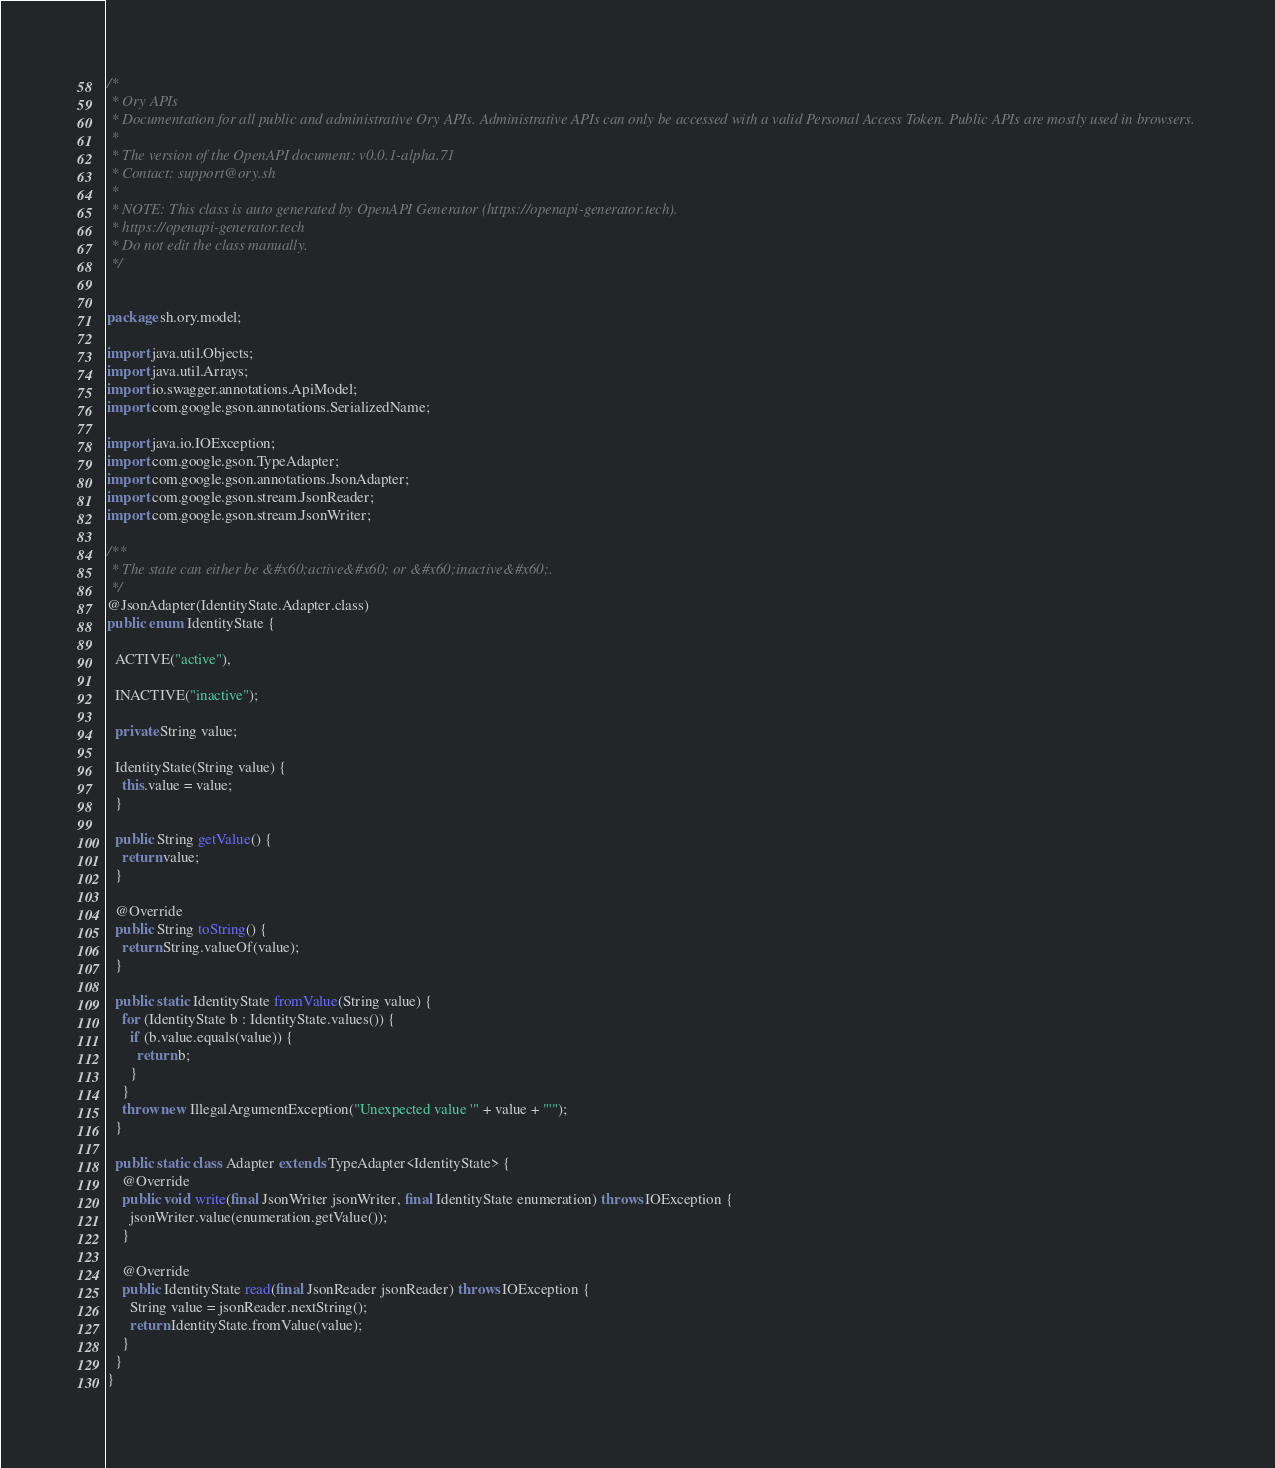<code> <loc_0><loc_0><loc_500><loc_500><_Java_>/*
 * Ory APIs
 * Documentation for all public and administrative Ory APIs. Administrative APIs can only be accessed with a valid Personal Access Token. Public APIs are mostly used in browsers. 
 *
 * The version of the OpenAPI document: v0.0.1-alpha.71
 * Contact: support@ory.sh
 *
 * NOTE: This class is auto generated by OpenAPI Generator (https://openapi-generator.tech).
 * https://openapi-generator.tech
 * Do not edit the class manually.
 */


package sh.ory.model;

import java.util.Objects;
import java.util.Arrays;
import io.swagger.annotations.ApiModel;
import com.google.gson.annotations.SerializedName;

import java.io.IOException;
import com.google.gson.TypeAdapter;
import com.google.gson.annotations.JsonAdapter;
import com.google.gson.stream.JsonReader;
import com.google.gson.stream.JsonWriter;

/**
 * The state can either be &#x60;active&#x60; or &#x60;inactive&#x60;.
 */
@JsonAdapter(IdentityState.Adapter.class)
public enum IdentityState {
  
  ACTIVE("active"),
  
  INACTIVE("inactive");

  private String value;

  IdentityState(String value) {
    this.value = value;
  }

  public String getValue() {
    return value;
  }

  @Override
  public String toString() {
    return String.valueOf(value);
  }

  public static IdentityState fromValue(String value) {
    for (IdentityState b : IdentityState.values()) {
      if (b.value.equals(value)) {
        return b;
      }
    }
    throw new IllegalArgumentException("Unexpected value '" + value + "'");
  }

  public static class Adapter extends TypeAdapter<IdentityState> {
    @Override
    public void write(final JsonWriter jsonWriter, final IdentityState enumeration) throws IOException {
      jsonWriter.value(enumeration.getValue());
    }

    @Override
    public IdentityState read(final JsonReader jsonReader) throws IOException {
      String value = jsonReader.nextString();
      return IdentityState.fromValue(value);
    }
  }
}

</code> 